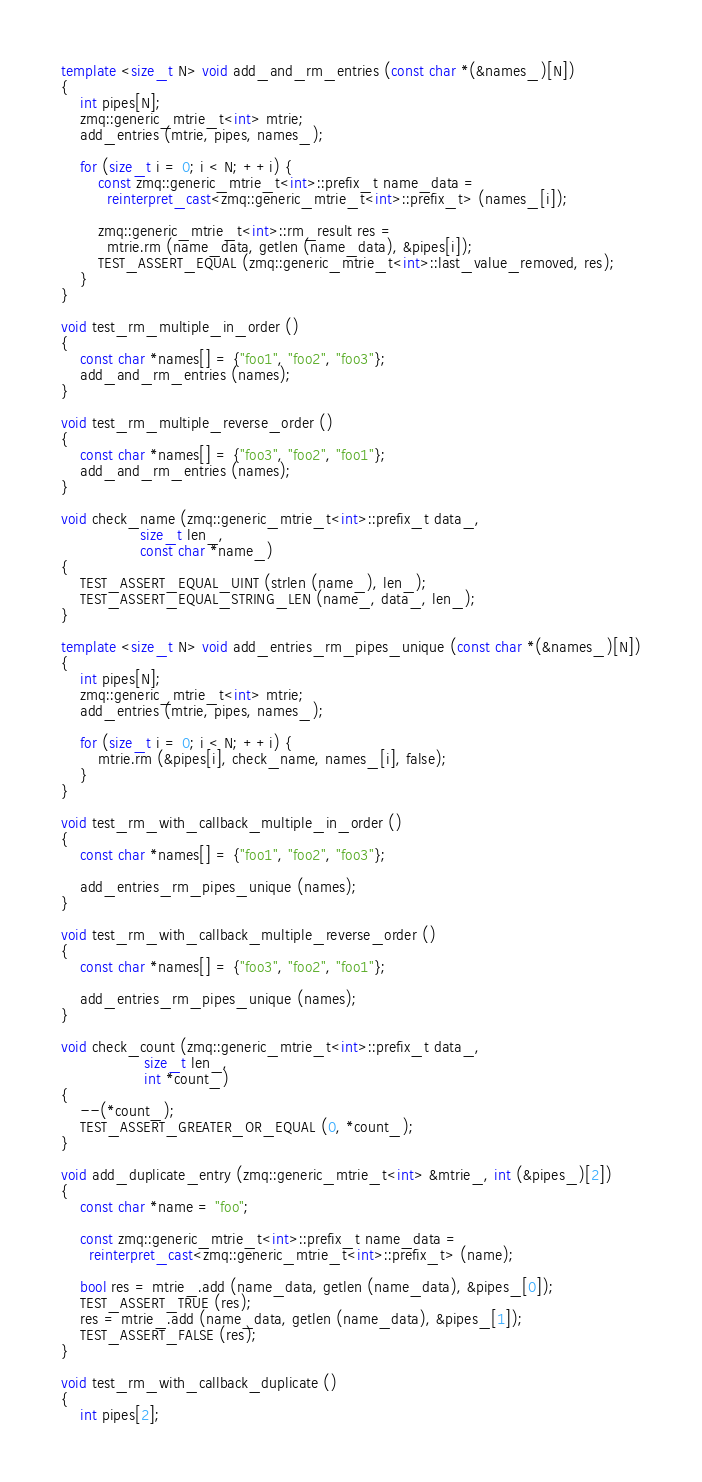Convert code to text. <code><loc_0><loc_0><loc_500><loc_500><_C++_>
template <size_t N> void add_and_rm_entries (const char *(&names_)[N])
{
    int pipes[N];
    zmq::generic_mtrie_t<int> mtrie;
    add_entries (mtrie, pipes, names_);

    for (size_t i = 0; i < N; ++i) {
        const zmq::generic_mtrie_t<int>::prefix_t name_data =
          reinterpret_cast<zmq::generic_mtrie_t<int>::prefix_t> (names_[i]);

        zmq::generic_mtrie_t<int>::rm_result res =
          mtrie.rm (name_data, getlen (name_data), &pipes[i]);
        TEST_ASSERT_EQUAL (zmq::generic_mtrie_t<int>::last_value_removed, res);
    }
}

void test_rm_multiple_in_order ()
{
    const char *names[] = {"foo1", "foo2", "foo3"};
    add_and_rm_entries (names);
}

void test_rm_multiple_reverse_order ()
{
    const char *names[] = {"foo3", "foo2", "foo1"};
    add_and_rm_entries (names);
}

void check_name (zmq::generic_mtrie_t<int>::prefix_t data_,
                 size_t len_,
                 const char *name_)
{
    TEST_ASSERT_EQUAL_UINT (strlen (name_), len_);
    TEST_ASSERT_EQUAL_STRING_LEN (name_, data_, len_);
}

template <size_t N> void add_entries_rm_pipes_unique (const char *(&names_)[N])
{
    int pipes[N];
    zmq::generic_mtrie_t<int> mtrie;
    add_entries (mtrie, pipes, names_);

    for (size_t i = 0; i < N; ++i) {
        mtrie.rm (&pipes[i], check_name, names_[i], false);
    }
}

void test_rm_with_callback_multiple_in_order ()
{
    const char *names[] = {"foo1", "foo2", "foo3"};

    add_entries_rm_pipes_unique (names);
}

void test_rm_with_callback_multiple_reverse_order ()
{
    const char *names[] = {"foo3", "foo2", "foo1"};

    add_entries_rm_pipes_unique (names);
}

void check_count (zmq::generic_mtrie_t<int>::prefix_t data_,
                  size_t len_,
                  int *count_)
{
    --(*count_);
    TEST_ASSERT_GREATER_OR_EQUAL (0, *count_);
}

void add_duplicate_entry (zmq::generic_mtrie_t<int> &mtrie_, int (&pipes_)[2])
{
    const char *name = "foo";

    const zmq::generic_mtrie_t<int>::prefix_t name_data =
      reinterpret_cast<zmq::generic_mtrie_t<int>::prefix_t> (name);

    bool res = mtrie_.add (name_data, getlen (name_data), &pipes_[0]);
    TEST_ASSERT_TRUE (res);
    res = mtrie_.add (name_data, getlen (name_data), &pipes_[1]);
    TEST_ASSERT_FALSE (res);
}

void test_rm_with_callback_duplicate ()
{
    int pipes[2];</code> 